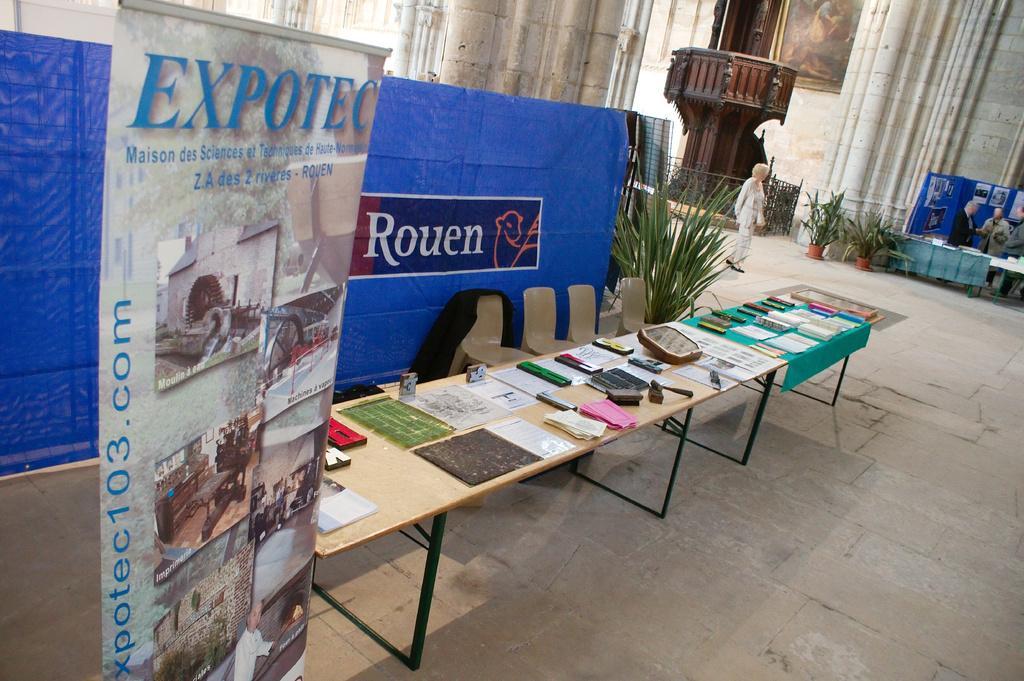Describe this image in one or two sentences. In this image i can see a table with few objects on it. I can also see there is a banner, a plant and a group of people are standing. 